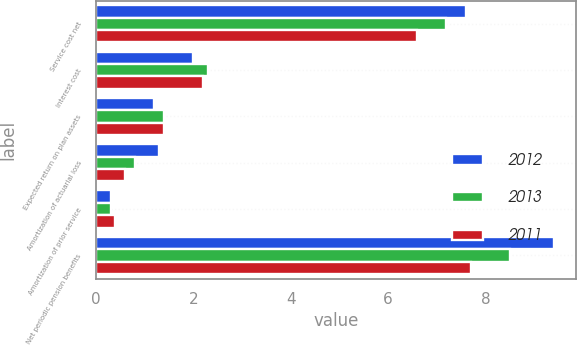Convert chart to OTSL. <chart><loc_0><loc_0><loc_500><loc_500><stacked_bar_chart><ecel><fcel>Service cost net<fcel>Interest cost<fcel>Expected return on plan assets<fcel>Amortization of actuarial loss<fcel>Amortization of prior service<fcel>Net periodic pension benefits<nl><fcel>2012<fcel>7.6<fcel>2<fcel>1.2<fcel>1.3<fcel>0.3<fcel>9.4<nl><fcel>2013<fcel>7.2<fcel>2.3<fcel>1.4<fcel>0.8<fcel>0.3<fcel>8.5<nl><fcel>2011<fcel>6.6<fcel>2.2<fcel>1.4<fcel>0.6<fcel>0.4<fcel>7.7<nl></chart> 